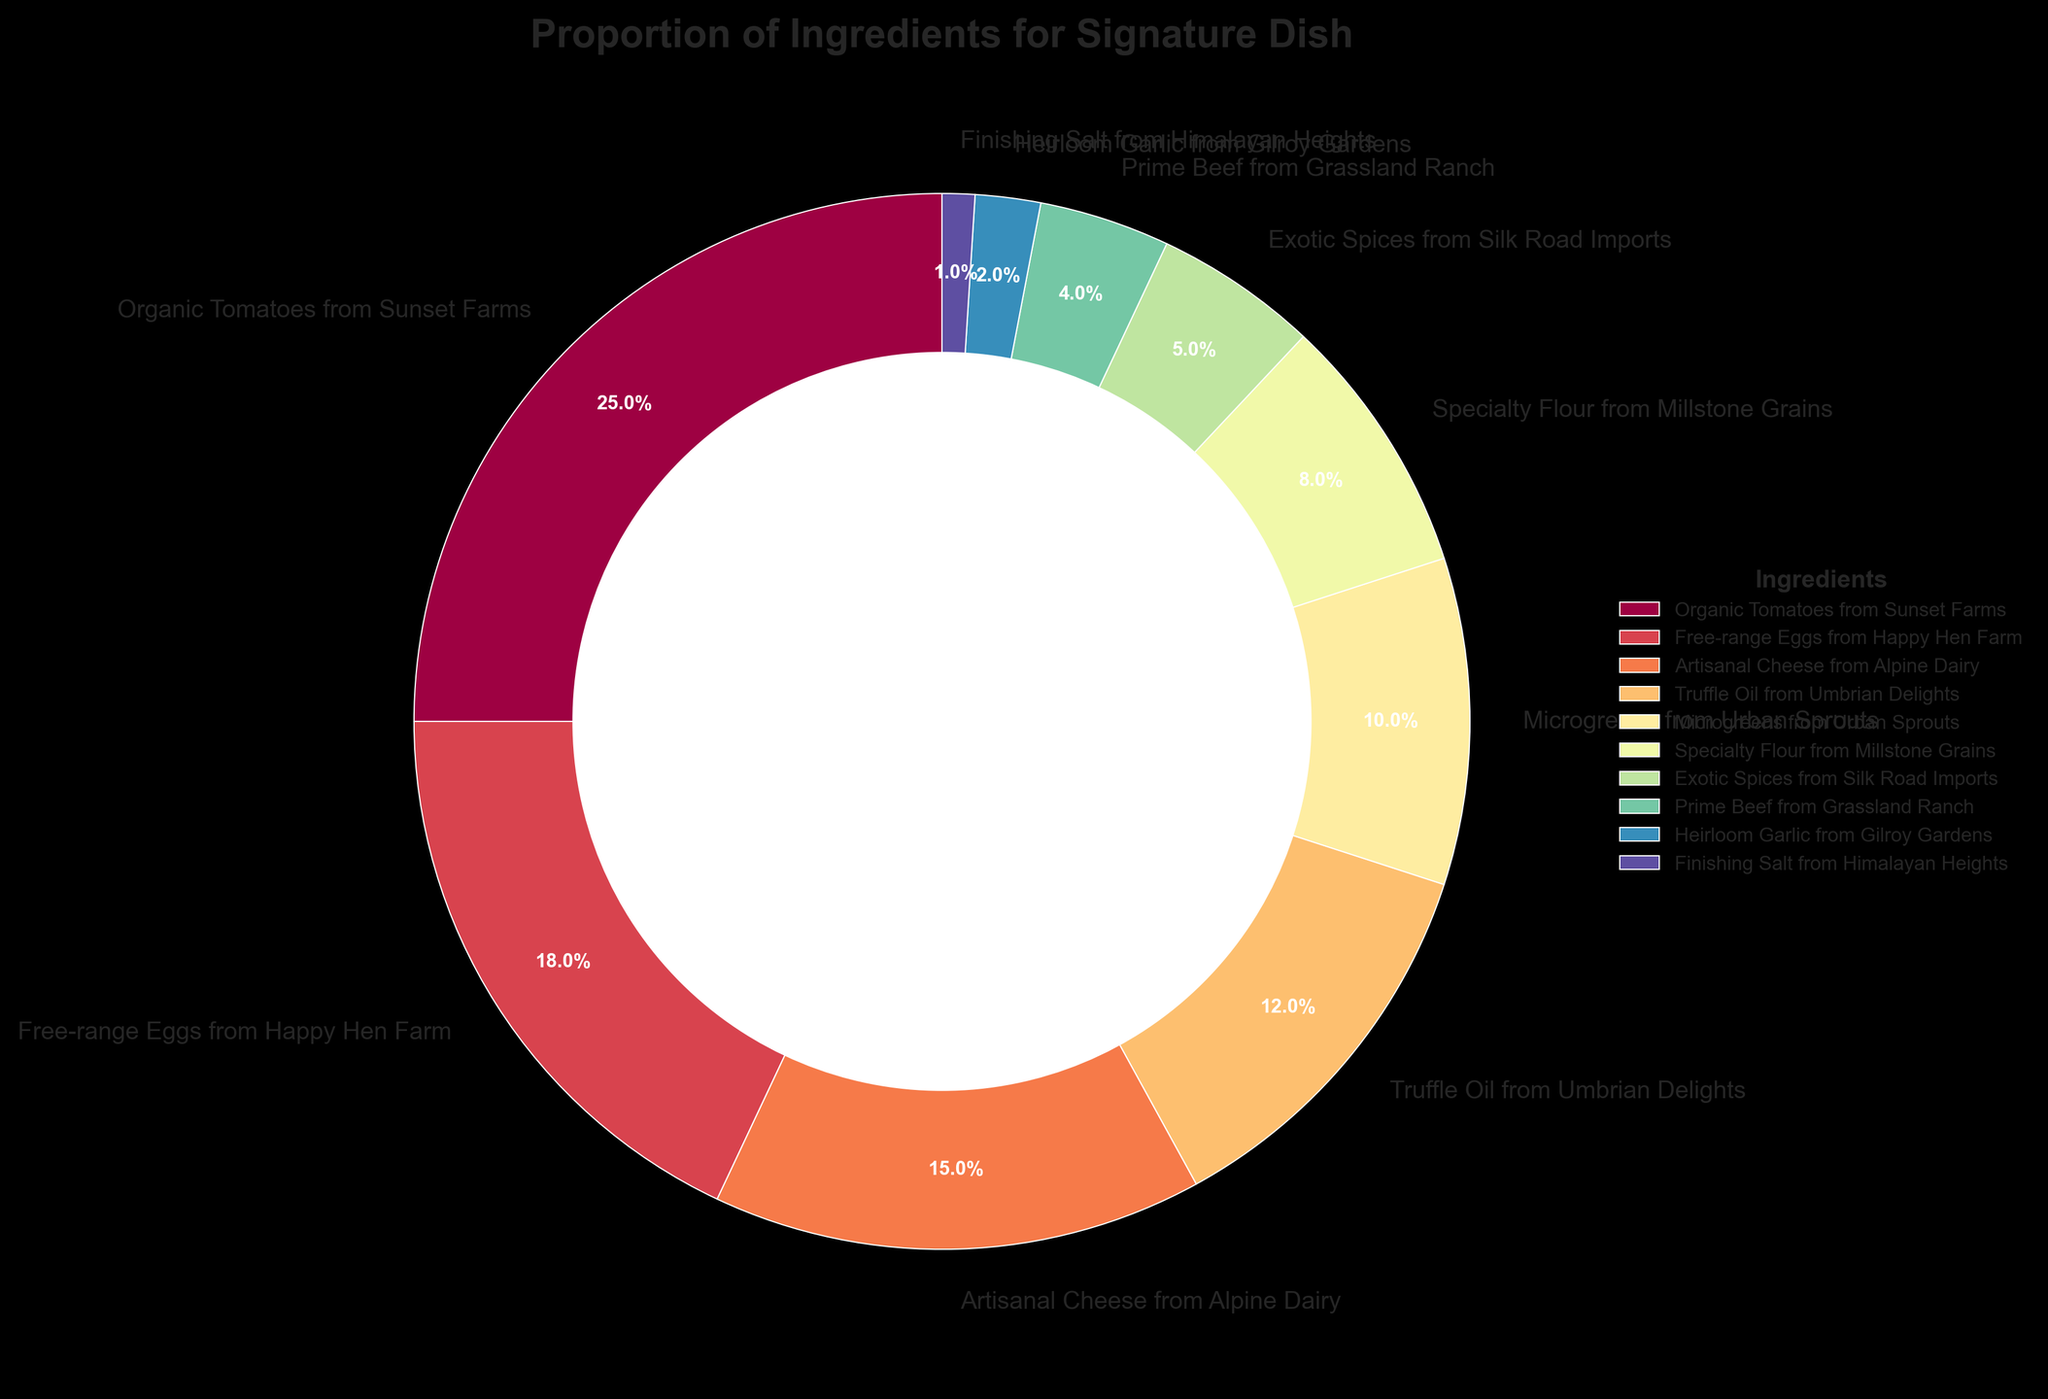What is the total percentage of ingredients sourced from Sunset Farms and Happy Hen Farm? To find the total percentage, add the percentages of Organic Tomatoes from Sunset Farms (25%) and Free-range Eggs from Happy Hen Farm (18%): 25 + 18 = 43
Answer: 43% Which ingredient has the lowest proportion in the signature dish? By examining the chart, the ingredient with the smallest percentage is Finishing Salt from Himalayan Heights at 1%.
Answer: Finishing Salt from Himalayan Heights How many ingredients have a proportion of 10% or more? Check the labels and percentages in the chart: Organic Tomatoes from Sunset Farms (25%), Free-range Eggs from Happy Hen Farm (18%), Artisanal Cheese from Alpine Dairy (15%), Truffle Oil from Umbrian Delights (12%), and Microgreens from Urban Sprouts (10%). There are 5 ingredients.
Answer: 5 Is the proportion of Artisanal Cheese from Alpine Dairy higher than that of Prime Beef from Grassland Ranch? Compare the percentages: Artisanal Cheese from Alpine Dairy is 15%, whereas Prime Beef from Grassland Ranch is 4%. Since 15 > 4, Artisanal Cheese has a higher proportion.
Answer: Yes What's the combined proportion of Artisanal Cheese, Microgreens, and Exotic Spices? Adding their percentages: Artisanal Cheese (15%) + Microgreens (10%) + Exotic Spices (5%) = 15 + 10 + 5 = 30
Answer: 30% Which ingredient is represented by the largest wedge in the pie chart? The largest wedge corresponds to the ingredient with the highest percentage, which is Organic Tomatoes from Sunset Farms at 25%.
Answer: Organic Tomatoes from Sunset Farms Is the percentage of Truffle Oil from Umbrian Delights double that of Specialty Flour from Millstone Grains? Compare the percentages: Truffle Oil (12%) and Specialty Flour (8%). Since 12 is not equal to 8 * 2, Truffle Oil is not double Specialty Flour.
Answer: No What is the difference in percentage points between Free-range Eggs from Happy Hen Farm and Heirloom Garlic from Gilroy Gardens? Subtract the percentage of Heirloom Garlic from Free-range Eggs: 18 - 2 = 16
Answer: 16 How does the proportion of Organic Tomatoes compare to that of Artisanal Cheese and Microgreens combined? Compare percentages: Organic Tomatoes (25%) vs. Artisanal Cheese (15%) + Microgreens (10%) = 25. Since the values are equal, their proportions are the same.
Answer: Equal Which ingredient sourced falls just below the threshold of having a double-digit percentage? The threshold for double digits is 10%. The ingredient with a percentage just below this is Specialty Flour from Millstone Grains at 8%.
Answer: Specialty Flour from Millstone Grains 